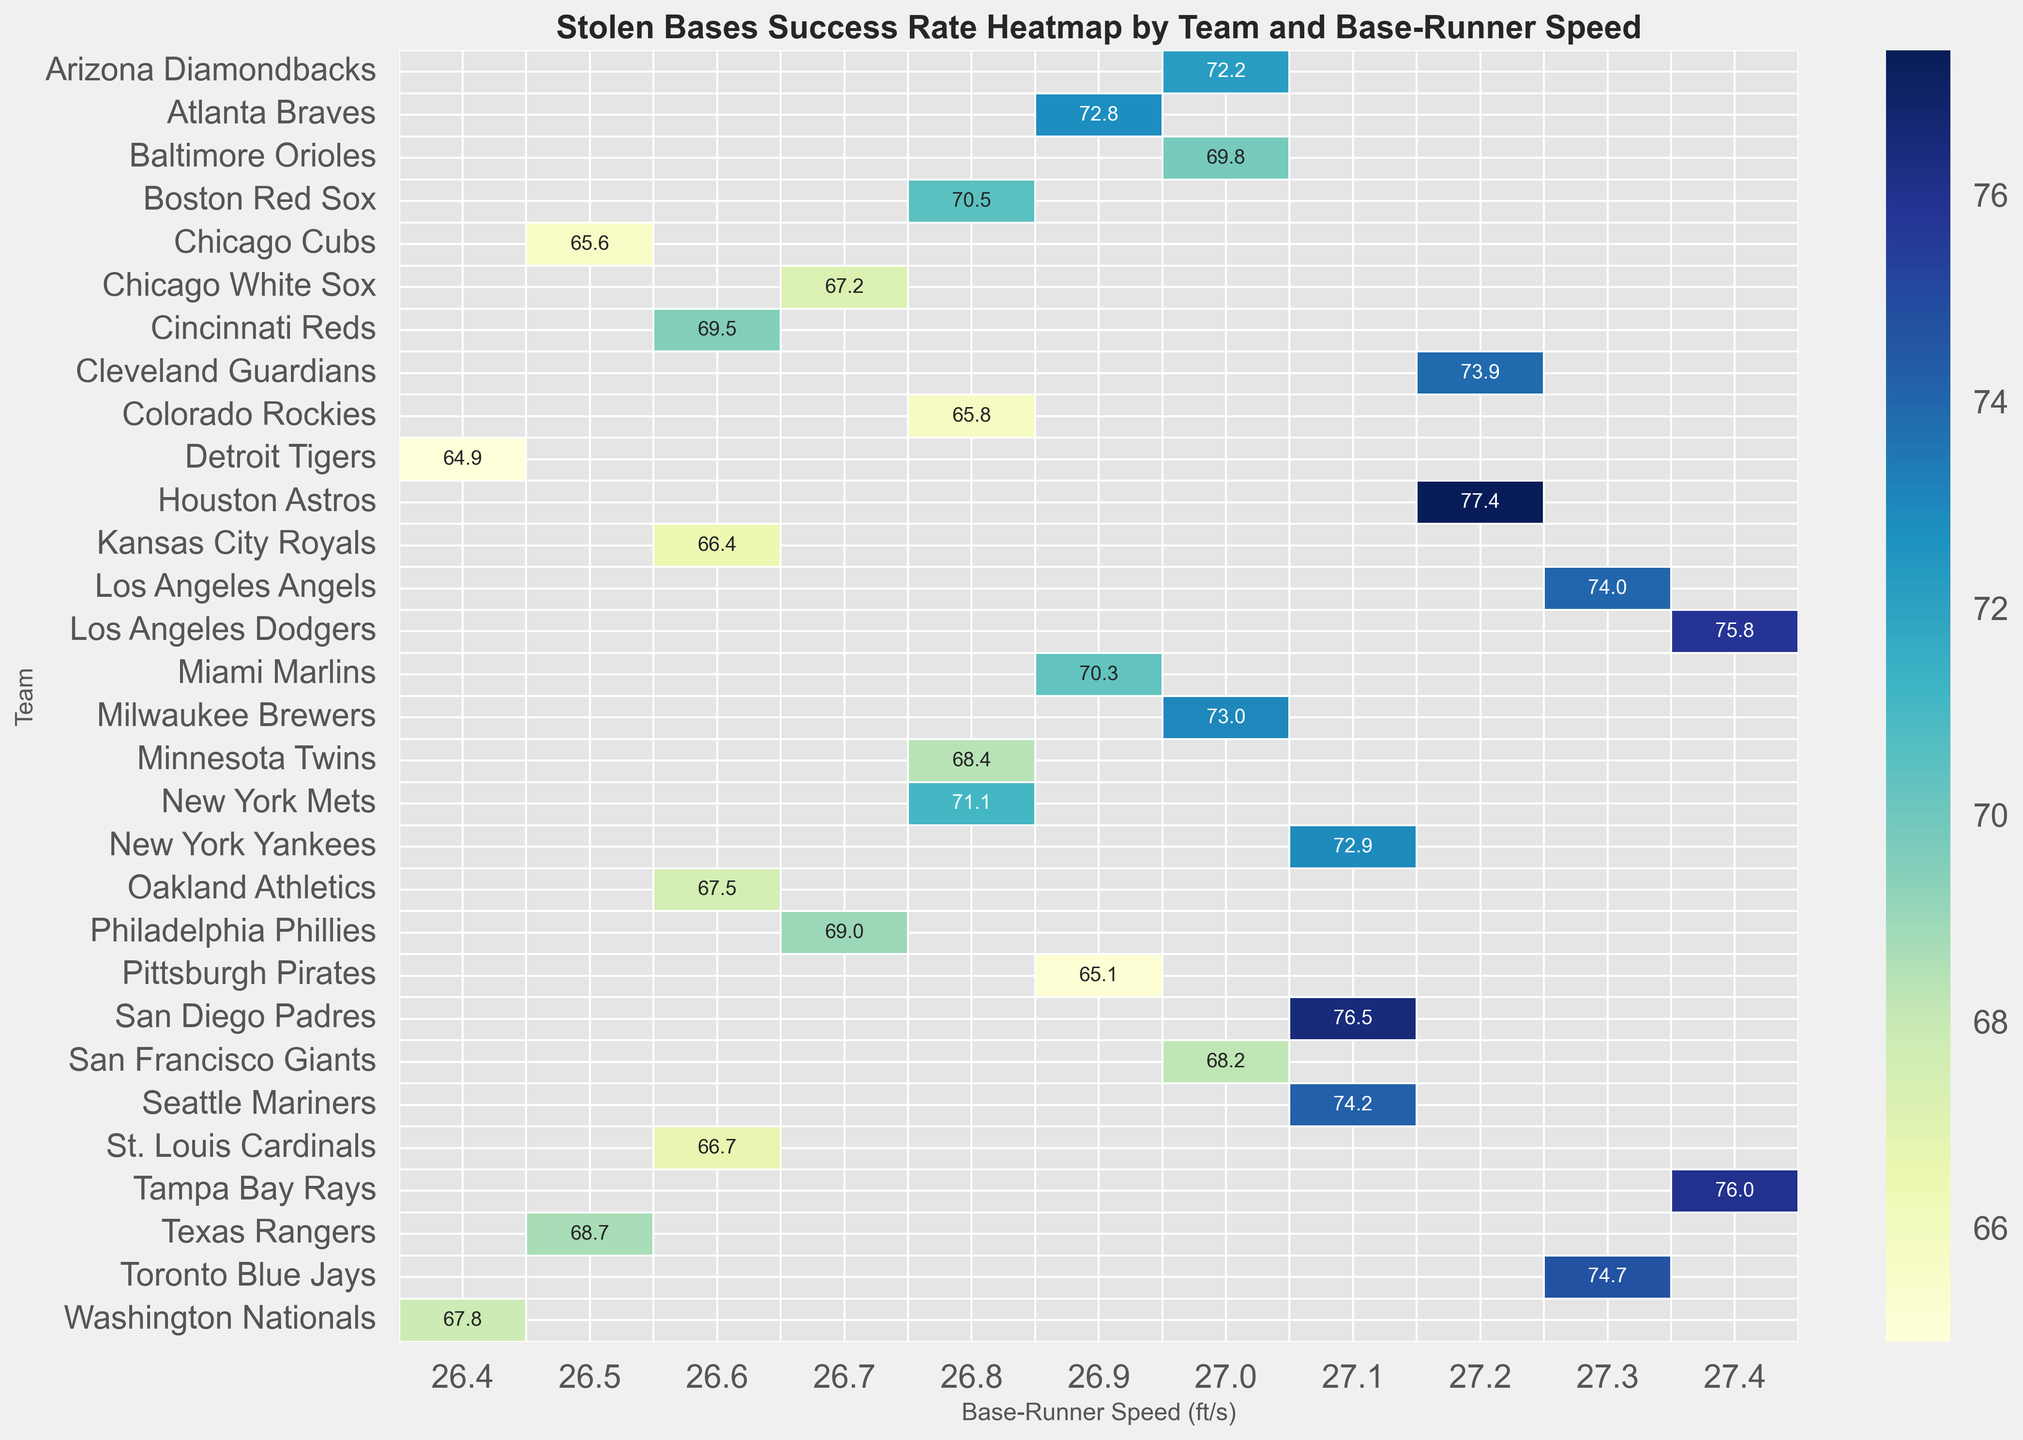Which team has the highest stolen bases success rate for a base-runner speed of 27.1 ft/s? Look at the column corresponding to the 27.1 ft/s base-runner speed and identify the highest stolen bases success rate among the teams listed.
Answer: Seattle Mariners How does the stolen bases success rate of the New York Yankees compare to the Chicago Cubs for their respective base-runner speeds? Compare the values in the stolen bases success rate for the New York Yankees (72.9%) and the Chicago Cubs (65.6%) at their respective base-runner speeds, 27.1 ft/s for the Yankees and 26.5 ft/s for the Cubs.
Answer: New York Yankees is higher Which team with a base-runner speed of 27.4 ft/s has a stolen bases success rate above 75%? Look at the column for 27.4 ft/s base-runner speed and identify teams that have stolen bases success rates above 75%, then pinpoint the team names.
Answer: Los Angeles Dodgers, Tampa Bay Rays Calculate the average stolen base success rate for teams with a base-runner speed of 26.6 ft/s. Add up the stolen base success rates for all teams with a base-runner speed of 26.6 ft/s: St. Louis Cardinals (66.7%), Cincinnati Reds (69.5%), Kansas City Royals (66.4%), and Oakland Athletics (67.5%), then divide by 4.
Answer: 67.525% Which team has the lowest stolen bases success rate for a base-runner speed of 27.0 ft/s? Look at the column for 27.0 ft/s base-runner speed and identify the lowest stolen bases success rate among the teams.
Answer: San Francisco Giants Compare the stolen bases success rates of teams with base-runner speeds of 27.2 ft/s and 27.3 ft/s. Which speed category has the higher average stolen bases success rate? Calculate the average stolen bases success rate for teams with 27.2 ft/s (Houston Astros, Cleveland Guardians) and those with 27.3 ft/s (Toronto Blue Jays, Los Angeles Angels). For 27.2 ft/s: (77.4 + 73.9) / 2 = 75.65%. For 27.3 ft/s: (74.7 + 74.0) / 2 = 74.35%. Compare both averages.
Answer: 27.2 ft/s What is the visual representation color for the highest stolen bases success rate on the heatmap? Identify the color that represents the box with the highest stolen bases success rate (most likely a darker or more saturated shade in the color spectrum), reinforcing the general pattern used in the heatmap.
Answer: Dark Blue 